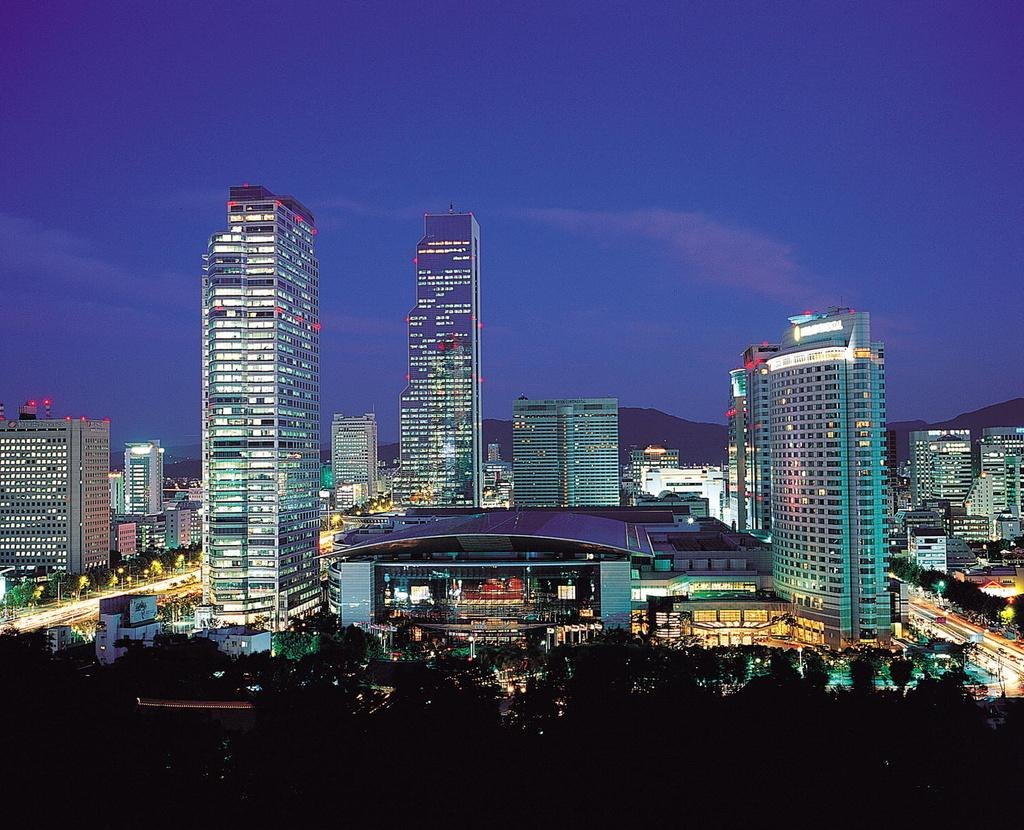What type of structures can be seen in the image? There are buildings in the image. What other natural elements are present in the image? There are trees in the image. What are the lights in the image used for? The lights in the image are likely used for illumination. What are the poles in the image used for? The poles in the image are likely used for supporting the lights or other infrastructure. What type of transportation is visible on the road in the image? There are vehicles on the road in the image. What type of geographical feature can be seen in the image? There are hills in the image. What is visible at the top of the image? The sky is visible at the top of the image. Where is the laborer sitting on a seat with a cup in the image? There is no laborer, seat, or cup present in the image. What type of cup is being used by the laborer in the image? There is no laborer, seat, or cup present in the image. 